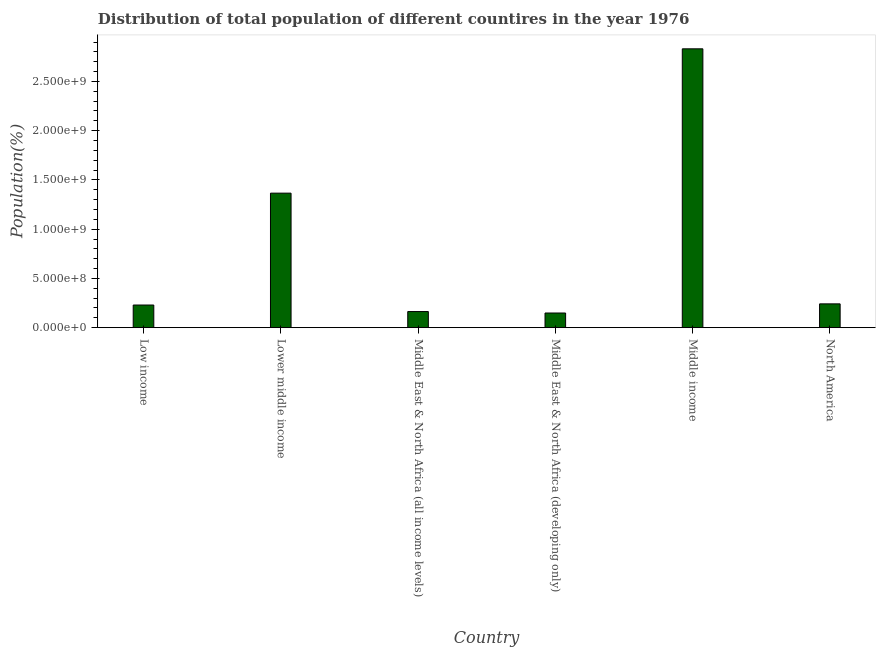Does the graph contain any zero values?
Make the answer very short. No. What is the title of the graph?
Your answer should be compact. Distribution of total population of different countires in the year 1976. What is the label or title of the Y-axis?
Offer a very short reply. Population(%). What is the population in Middle income?
Make the answer very short. 2.83e+09. Across all countries, what is the maximum population?
Offer a terse response. 2.83e+09. Across all countries, what is the minimum population?
Ensure brevity in your answer.  1.49e+08. In which country was the population maximum?
Make the answer very short. Middle income. In which country was the population minimum?
Provide a succinct answer. Middle East & North Africa (developing only). What is the sum of the population?
Your answer should be compact. 4.98e+09. What is the difference between the population in Lower middle income and Middle East & North Africa (all income levels)?
Your answer should be very brief. 1.20e+09. What is the average population per country?
Give a very brief answer. 8.30e+08. What is the median population?
Provide a short and direct response. 2.36e+08. What is the ratio of the population in Lower middle income to that in Middle East & North Africa (all income levels)?
Your answer should be very brief. 8.35. What is the difference between the highest and the second highest population?
Ensure brevity in your answer.  1.47e+09. What is the difference between the highest and the lowest population?
Your response must be concise. 2.68e+09. In how many countries, is the population greater than the average population taken over all countries?
Your answer should be very brief. 2. How many bars are there?
Provide a short and direct response. 6. How many countries are there in the graph?
Keep it short and to the point. 6. What is the difference between two consecutive major ticks on the Y-axis?
Provide a succinct answer. 5.00e+08. Are the values on the major ticks of Y-axis written in scientific E-notation?
Make the answer very short. Yes. What is the Population(%) of Low income?
Give a very brief answer. 2.30e+08. What is the Population(%) in Lower middle income?
Give a very brief answer. 1.37e+09. What is the Population(%) in Middle East & North Africa (all income levels)?
Provide a succinct answer. 1.64e+08. What is the Population(%) of Middle East & North Africa (developing only)?
Your answer should be compact. 1.49e+08. What is the Population(%) of Middle income?
Provide a succinct answer. 2.83e+09. What is the Population(%) in North America?
Provide a succinct answer. 2.42e+08. What is the difference between the Population(%) in Low income and Lower middle income?
Make the answer very short. -1.14e+09. What is the difference between the Population(%) in Low income and Middle East & North Africa (all income levels)?
Keep it short and to the point. 6.63e+07. What is the difference between the Population(%) in Low income and Middle East & North Africa (developing only)?
Make the answer very short. 8.11e+07. What is the difference between the Population(%) in Low income and Middle income?
Make the answer very short. -2.60e+09. What is the difference between the Population(%) in Low income and North America?
Ensure brevity in your answer.  -1.17e+07. What is the difference between the Population(%) in Lower middle income and Middle East & North Africa (all income levels)?
Give a very brief answer. 1.20e+09. What is the difference between the Population(%) in Lower middle income and Middle East & North Africa (developing only)?
Offer a terse response. 1.22e+09. What is the difference between the Population(%) in Lower middle income and Middle income?
Keep it short and to the point. -1.47e+09. What is the difference between the Population(%) in Lower middle income and North America?
Your answer should be compact. 1.12e+09. What is the difference between the Population(%) in Middle East & North Africa (all income levels) and Middle East & North Africa (developing only)?
Your response must be concise. 1.48e+07. What is the difference between the Population(%) in Middle East & North Africa (all income levels) and Middle income?
Keep it short and to the point. -2.67e+09. What is the difference between the Population(%) in Middle East & North Africa (all income levels) and North America?
Your answer should be compact. -7.80e+07. What is the difference between the Population(%) in Middle East & North Africa (developing only) and Middle income?
Provide a short and direct response. -2.68e+09. What is the difference between the Population(%) in Middle East & North Africa (developing only) and North America?
Offer a terse response. -9.29e+07. What is the difference between the Population(%) in Middle income and North America?
Your answer should be very brief. 2.59e+09. What is the ratio of the Population(%) in Low income to that in Lower middle income?
Give a very brief answer. 0.17. What is the ratio of the Population(%) in Low income to that in Middle East & North Africa (all income levels)?
Offer a very short reply. 1.41. What is the ratio of the Population(%) in Low income to that in Middle East & North Africa (developing only)?
Offer a terse response. 1.54. What is the ratio of the Population(%) in Low income to that in Middle income?
Offer a terse response. 0.08. What is the ratio of the Population(%) in Low income to that in North America?
Give a very brief answer. 0.95. What is the ratio of the Population(%) in Lower middle income to that in Middle East & North Africa (all income levels)?
Offer a terse response. 8.35. What is the ratio of the Population(%) in Lower middle income to that in Middle East & North Africa (developing only)?
Offer a very short reply. 9.18. What is the ratio of the Population(%) in Lower middle income to that in Middle income?
Offer a terse response. 0.48. What is the ratio of the Population(%) in Lower middle income to that in North America?
Provide a short and direct response. 5.65. What is the ratio of the Population(%) in Middle East & North Africa (all income levels) to that in Middle East & North Africa (developing only)?
Your response must be concise. 1.1. What is the ratio of the Population(%) in Middle East & North Africa (all income levels) to that in Middle income?
Your response must be concise. 0.06. What is the ratio of the Population(%) in Middle East & North Africa (all income levels) to that in North America?
Ensure brevity in your answer.  0.68. What is the ratio of the Population(%) in Middle East & North Africa (developing only) to that in Middle income?
Your response must be concise. 0.05. What is the ratio of the Population(%) in Middle East & North Africa (developing only) to that in North America?
Make the answer very short. 0.62. What is the ratio of the Population(%) in Middle income to that in North America?
Offer a very short reply. 11.72. 